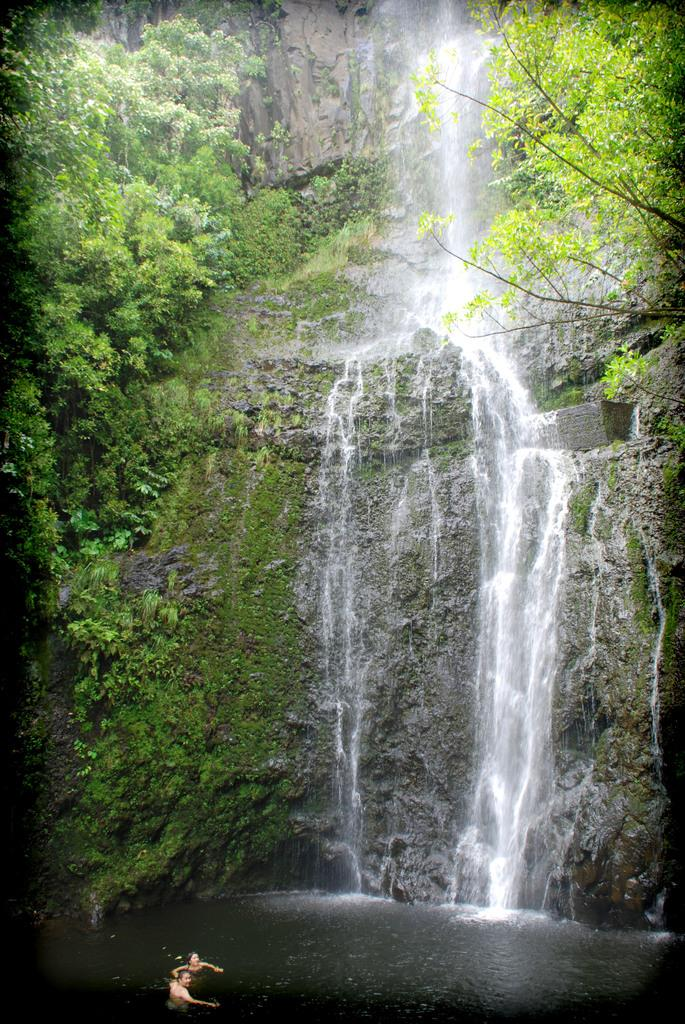What are the two people in the image doing? The two people in the image are swimming in the water. What can be seen on the right side of the image? There are trees on the right side of the image. What is the main feature in the middle of the image? There is a waterfall in the middle of the image. What is present on the left side of the image? There are trees on the left side of the image. What type of structure can be seen in the water near the swimmers? There is no structure visible in the water near the swimmers; it is just the two people swimming. Is there a ship sailing in the water in the image? No, there is no ship present in the image. 